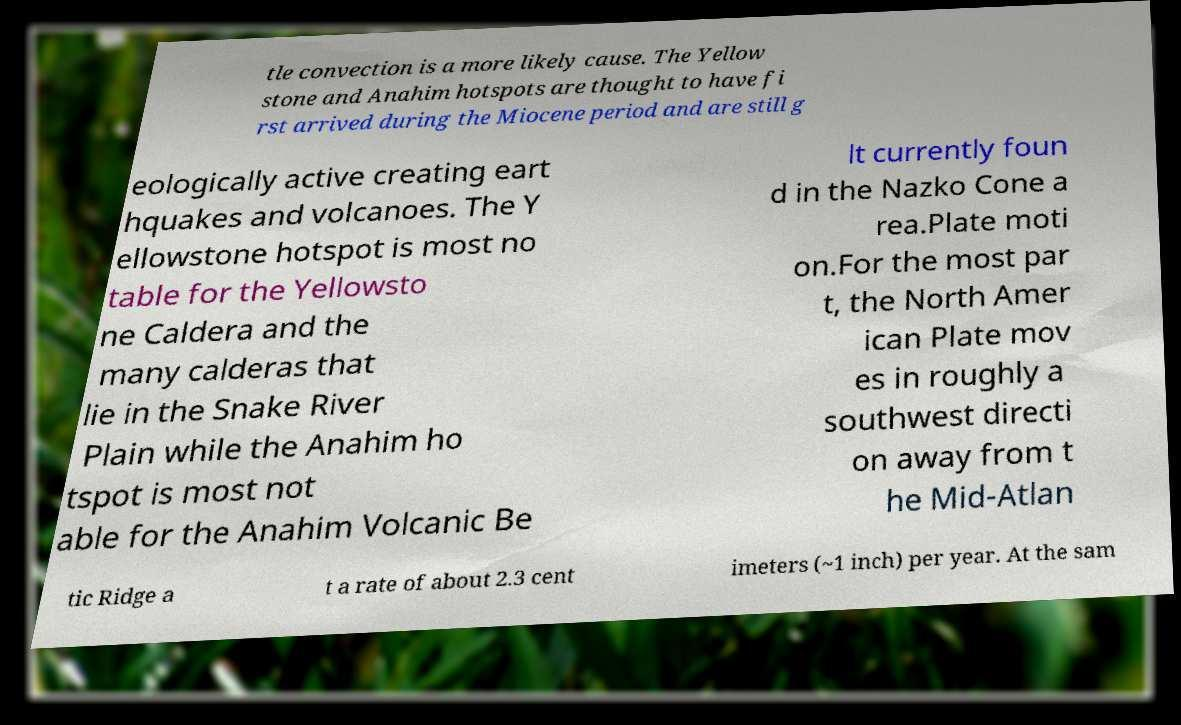Could you assist in decoding the text presented in this image and type it out clearly? tle convection is a more likely cause. The Yellow stone and Anahim hotspots are thought to have fi rst arrived during the Miocene period and are still g eologically active creating eart hquakes and volcanoes. The Y ellowstone hotspot is most no table for the Yellowsto ne Caldera and the many calderas that lie in the Snake River Plain while the Anahim ho tspot is most not able for the Anahim Volcanic Be lt currently foun d in the Nazko Cone a rea.Plate moti on.For the most par t, the North Amer ican Plate mov es in roughly a southwest directi on away from t he Mid-Atlan tic Ridge a t a rate of about 2.3 cent imeters (~1 inch) per year. At the sam 